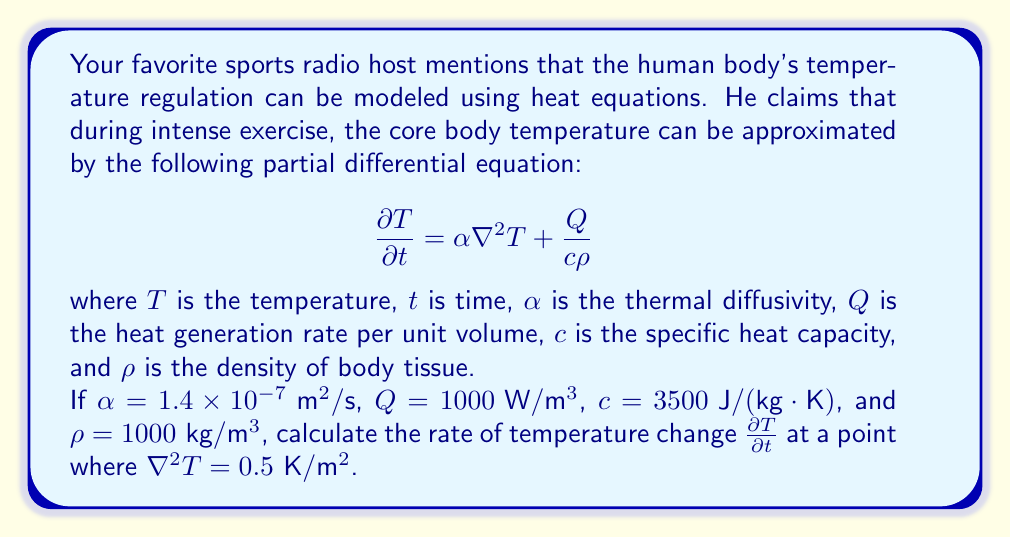What is the answer to this math problem? To solve this problem, we'll follow these steps:

1) The given heat equation is:

   $$\frac{\partial T}{\partial t} = \alpha \nabla^2 T + \frac{Q}{c\rho}$$

2) We're given the following values:
   - $\alpha = 1.4 \times 10^{-7} \text{ m}^2/\text{s}$
   - $Q = 1000 \text{ W}/\text{m}^3$
   - $c = 3500 \text{ J}/(\text{kg} \cdot \text{K})$
   - $\rho = 1000 \text{ kg}/\text{m}^3$
   - $\nabla^2 T = 0.5 \text{ K}/\text{m}^2$

3) Let's calculate the first term $\alpha \nabla^2 T$:

   $\alpha \nabla^2 T = (1.4 \times 10^{-7} \text{ m}^2/\text{s})(0.5 \text{ K}/\text{m}^2) = 7 \times 10^{-8} \text{ K}/\text{s}$

4) Now, let's calculate the second term $\frac{Q}{c\rho}$:

   $\frac{Q}{c\rho} = \frac{1000 \text{ W}/\text{m}^3}{(3500 \text{ J}/(\text{kg} \cdot \text{K}))(1000 \text{ kg}/\text{m}^3)} = \frac{1000}{3500000} \text{ K}/\text{s} = 2.86 \times 10^{-4} \text{ K}/\text{s}$

5) The rate of temperature change $\frac{\partial T}{\partial t}$ is the sum of these two terms:

   $\frac{\partial T}{\partial t} = (7 \times 10^{-8} + 2.86 \times 10^{-4}) \text{ K}/\text{s} = 2.867 \times 10^{-4} \text{ K}/\text{s}$
Answer: $2.867 \times 10^{-4} \text{ K}/\text{s}$ 